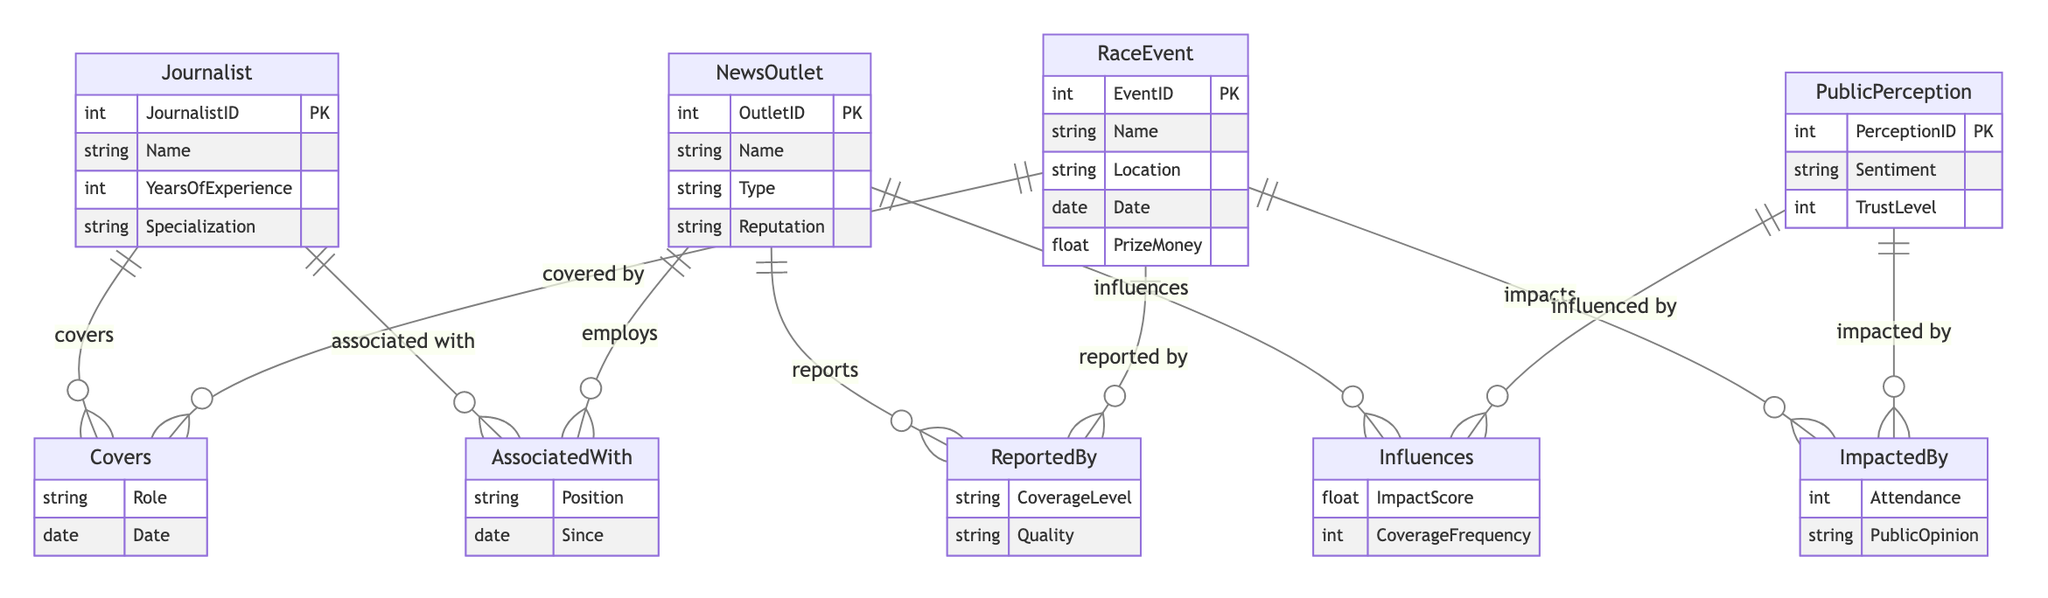What is the primary relationship between Journalist and RaceEvent? The primary relationship illustrated in the diagram between Journalist and RaceEvent is that a Journalist "Covers" a RaceEvent. This indicates the role of the journalist in relation to specific racing events.
Answer: Covers How many entities are present in the diagram? The diagram shows four entities: Journalist, NewsOutlet, RaceEvent, and PublicPerception. Therefore, the total count of entities is four.
Answer: 4 What attribute defines the reputation of a NewsOutlet? The reputation of a NewsOutlet is defined by the attribute "Reputation", which indicates how it is perceived publicly.
Answer: Reputation Which entity is associated with the attribute "CoverageLevel"? The attribute "CoverageLevel" is associated with the relationship between NewsOutlet and RaceEvent, specifically in the context of how a NewsOutlet "Reports" on a RaceEvent.
Answer: RaceEvent Which relationship connects RaceEvent and PublicPerception? The relationship that connects RaceEvent and PublicPerception is termed "ImpactedBy", indicating how a RaceEvent influences the public's perception of it.
Answer: ImpactedBy What is the significance of the attribute "ImpactScore"? The attribute "ImpactScore" is significant because it indicates the extent to which a NewsOutlet "Influences" PublicPerception, reflecting a quantitative measure of that influence.
Answer: ImpactScore How many attributes does the Journalist entity have? The Journalist entity contains four attributes: JournalistID, Name, YearsOfExperience, and Specialization. Therefore, there are four attributes in total.
Answer: 4 Which entities are involved in the relationship "AssociatedWith"? The relationship "AssociatedWith" involves two entities: Journalist and NewsOutlet. This shows how journalists are linked to the news outlets they work for.
Answer: Journalist, NewsOutlet What influences the TrustLevel in PublicPerception? The TrustLevel in PublicPerception is influenced by various factors indicated in the diagram, particularly the relationship "Influences" involving NewsOutlet and its coverage frequency, alongside the perceptions formed from race events.
Answer: NewsOutlet, RaceEvent 